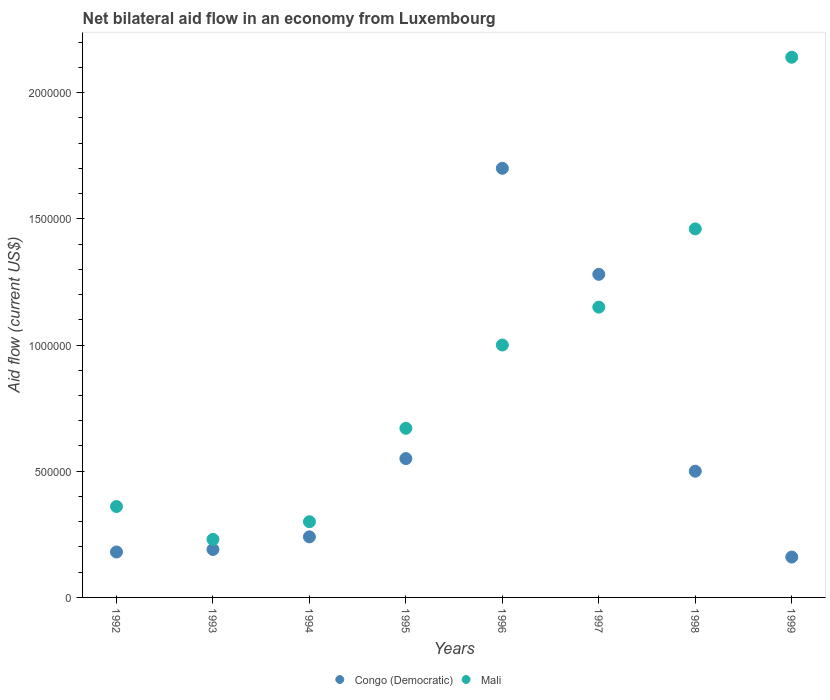What is the net bilateral aid flow in Congo (Democratic) in 1996?
Offer a very short reply. 1.70e+06. Across all years, what is the maximum net bilateral aid flow in Congo (Democratic)?
Ensure brevity in your answer.  1.70e+06. Across all years, what is the minimum net bilateral aid flow in Congo (Democratic)?
Provide a short and direct response. 1.60e+05. In which year was the net bilateral aid flow in Congo (Democratic) maximum?
Provide a succinct answer. 1996. What is the total net bilateral aid flow in Mali in the graph?
Make the answer very short. 7.31e+06. What is the difference between the net bilateral aid flow in Mali in 1992 and that in 1995?
Your answer should be compact. -3.10e+05. What is the difference between the net bilateral aid flow in Mali in 1998 and the net bilateral aid flow in Congo (Democratic) in 1997?
Provide a succinct answer. 1.80e+05. What is the average net bilateral aid flow in Mali per year?
Keep it short and to the point. 9.14e+05. In the year 1996, what is the difference between the net bilateral aid flow in Mali and net bilateral aid flow in Congo (Democratic)?
Your response must be concise. -7.00e+05. What is the ratio of the net bilateral aid flow in Mali in 1994 to that in 1999?
Ensure brevity in your answer.  0.14. What is the difference between the highest and the lowest net bilateral aid flow in Congo (Democratic)?
Make the answer very short. 1.54e+06. In how many years, is the net bilateral aid flow in Congo (Democratic) greater than the average net bilateral aid flow in Congo (Democratic) taken over all years?
Offer a very short reply. 2. Is the sum of the net bilateral aid flow in Congo (Democratic) in 1994 and 1997 greater than the maximum net bilateral aid flow in Mali across all years?
Keep it short and to the point. No. Does the net bilateral aid flow in Congo (Democratic) monotonically increase over the years?
Your response must be concise. No. Is the net bilateral aid flow in Congo (Democratic) strictly less than the net bilateral aid flow in Mali over the years?
Keep it short and to the point. No. How many years are there in the graph?
Make the answer very short. 8. Are the values on the major ticks of Y-axis written in scientific E-notation?
Give a very brief answer. No. Does the graph contain any zero values?
Offer a very short reply. No. How many legend labels are there?
Offer a terse response. 2. What is the title of the graph?
Keep it short and to the point. Net bilateral aid flow in an economy from Luxembourg. What is the label or title of the X-axis?
Your response must be concise. Years. What is the Aid flow (current US$) of Congo (Democratic) in 1992?
Ensure brevity in your answer.  1.80e+05. What is the Aid flow (current US$) of Mali in 1992?
Ensure brevity in your answer.  3.60e+05. What is the Aid flow (current US$) of Mali in 1993?
Keep it short and to the point. 2.30e+05. What is the Aid flow (current US$) of Congo (Democratic) in 1994?
Ensure brevity in your answer.  2.40e+05. What is the Aid flow (current US$) in Congo (Democratic) in 1995?
Give a very brief answer. 5.50e+05. What is the Aid flow (current US$) of Mali in 1995?
Provide a short and direct response. 6.70e+05. What is the Aid flow (current US$) of Congo (Democratic) in 1996?
Offer a terse response. 1.70e+06. What is the Aid flow (current US$) of Congo (Democratic) in 1997?
Offer a terse response. 1.28e+06. What is the Aid flow (current US$) of Mali in 1997?
Make the answer very short. 1.15e+06. What is the Aid flow (current US$) of Mali in 1998?
Give a very brief answer. 1.46e+06. What is the Aid flow (current US$) of Mali in 1999?
Your answer should be very brief. 2.14e+06. Across all years, what is the maximum Aid flow (current US$) of Congo (Democratic)?
Offer a very short reply. 1.70e+06. Across all years, what is the maximum Aid flow (current US$) of Mali?
Ensure brevity in your answer.  2.14e+06. Across all years, what is the minimum Aid flow (current US$) in Mali?
Give a very brief answer. 2.30e+05. What is the total Aid flow (current US$) of Congo (Democratic) in the graph?
Provide a short and direct response. 4.80e+06. What is the total Aid flow (current US$) in Mali in the graph?
Your answer should be very brief. 7.31e+06. What is the difference between the Aid flow (current US$) of Congo (Democratic) in 1992 and that in 1993?
Provide a succinct answer. -10000. What is the difference between the Aid flow (current US$) in Congo (Democratic) in 1992 and that in 1994?
Provide a short and direct response. -6.00e+04. What is the difference between the Aid flow (current US$) of Mali in 1992 and that in 1994?
Keep it short and to the point. 6.00e+04. What is the difference between the Aid flow (current US$) in Congo (Democratic) in 1992 and that in 1995?
Your answer should be compact. -3.70e+05. What is the difference between the Aid flow (current US$) of Mali in 1992 and that in 1995?
Your answer should be compact. -3.10e+05. What is the difference between the Aid flow (current US$) of Congo (Democratic) in 1992 and that in 1996?
Provide a short and direct response. -1.52e+06. What is the difference between the Aid flow (current US$) in Mali in 1992 and that in 1996?
Offer a very short reply. -6.40e+05. What is the difference between the Aid flow (current US$) of Congo (Democratic) in 1992 and that in 1997?
Give a very brief answer. -1.10e+06. What is the difference between the Aid flow (current US$) of Mali in 1992 and that in 1997?
Your response must be concise. -7.90e+05. What is the difference between the Aid flow (current US$) in Congo (Democratic) in 1992 and that in 1998?
Your response must be concise. -3.20e+05. What is the difference between the Aid flow (current US$) in Mali in 1992 and that in 1998?
Your response must be concise. -1.10e+06. What is the difference between the Aid flow (current US$) in Congo (Democratic) in 1992 and that in 1999?
Your response must be concise. 2.00e+04. What is the difference between the Aid flow (current US$) in Mali in 1992 and that in 1999?
Offer a very short reply. -1.78e+06. What is the difference between the Aid flow (current US$) in Mali in 1993 and that in 1994?
Offer a very short reply. -7.00e+04. What is the difference between the Aid flow (current US$) in Congo (Democratic) in 1993 and that in 1995?
Your answer should be very brief. -3.60e+05. What is the difference between the Aid flow (current US$) in Mali in 1993 and that in 1995?
Your answer should be very brief. -4.40e+05. What is the difference between the Aid flow (current US$) of Congo (Democratic) in 1993 and that in 1996?
Offer a very short reply. -1.51e+06. What is the difference between the Aid flow (current US$) in Mali in 1993 and that in 1996?
Your response must be concise. -7.70e+05. What is the difference between the Aid flow (current US$) in Congo (Democratic) in 1993 and that in 1997?
Keep it short and to the point. -1.09e+06. What is the difference between the Aid flow (current US$) of Mali in 1993 and that in 1997?
Offer a terse response. -9.20e+05. What is the difference between the Aid flow (current US$) in Congo (Democratic) in 1993 and that in 1998?
Provide a succinct answer. -3.10e+05. What is the difference between the Aid flow (current US$) in Mali in 1993 and that in 1998?
Give a very brief answer. -1.23e+06. What is the difference between the Aid flow (current US$) in Mali in 1993 and that in 1999?
Provide a short and direct response. -1.91e+06. What is the difference between the Aid flow (current US$) of Congo (Democratic) in 1994 and that in 1995?
Provide a short and direct response. -3.10e+05. What is the difference between the Aid flow (current US$) in Mali in 1994 and that in 1995?
Make the answer very short. -3.70e+05. What is the difference between the Aid flow (current US$) of Congo (Democratic) in 1994 and that in 1996?
Ensure brevity in your answer.  -1.46e+06. What is the difference between the Aid flow (current US$) in Mali in 1994 and that in 1996?
Give a very brief answer. -7.00e+05. What is the difference between the Aid flow (current US$) of Congo (Democratic) in 1994 and that in 1997?
Your answer should be very brief. -1.04e+06. What is the difference between the Aid flow (current US$) in Mali in 1994 and that in 1997?
Your answer should be compact. -8.50e+05. What is the difference between the Aid flow (current US$) of Mali in 1994 and that in 1998?
Offer a very short reply. -1.16e+06. What is the difference between the Aid flow (current US$) of Mali in 1994 and that in 1999?
Provide a short and direct response. -1.84e+06. What is the difference between the Aid flow (current US$) of Congo (Democratic) in 1995 and that in 1996?
Your answer should be very brief. -1.15e+06. What is the difference between the Aid flow (current US$) of Mali in 1995 and that in 1996?
Provide a succinct answer. -3.30e+05. What is the difference between the Aid flow (current US$) in Congo (Democratic) in 1995 and that in 1997?
Make the answer very short. -7.30e+05. What is the difference between the Aid flow (current US$) of Mali in 1995 and that in 1997?
Give a very brief answer. -4.80e+05. What is the difference between the Aid flow (current US$) of Mali in 1995 and that in 1998?
Offer a terse response. -7.90e+05. What is the difference between the Aid flow (current US$) of Mali in 1995 and that in 1999?
Make the answer very short. -1.47e+06. What is the difference between the Aid flow (current US$) of Congo (Democratic) in 1996 and that in 1997?
Your answer should be compact. 4.20e+05. What is the difference between the Aid flow (current US$) of Mali in 1996 and that in 1997?
Provide a succinct answer. -1.50e+05. What is the difference between the Aid flow (current US$) in Congo (Democratic) in 1996 and that in 1998?
Your answer should be very brief. 1.20e+06. What is the difference between the Aid flow (current US$) of Mali in 1996 and that in 1998?
Your answer should be compact. -4.60e+05. What is the difference between the Aid flow (current US$) of Congo (Democratic) in 1996 and that in 1999?
Your answer should be very brief. 1.54e+06. What is the difference between the Aid flow (current US$) of Mali in 1996 and that in 1999?
Offer a terse response. -1.14e+06. What is the difference between the Aid flow (current US$) in Congo (Democratic) in 1997 and that in 1998?
Your answer should be very brief. 7.80e+05. What is the difference between the Aid flow (current US$) in Mali in 1997 and that in 1998?
Keep it short and to the point. -3.10e+05. What is the difference between the Aid flow (current US$) of Congo (Democratic) in 1997 and that in 1999?
Your response must be concise. 1.12e+06. What is the difference between the Aid flow (current US$) of Mali in 1997 and that in 1999?
Your answer should be very brief. -9.90e+05. What is the difference between the Aid flow (current US$) in Congo (Democratic) in 1998 and that in 1999?
Your answer should be compact. 3.40e+05. What is the difference between the Aid flow (current US$) of Mali in 1998 and that in 1999?
Provide a succinct answer. -6.80e+05. What is the difference between the Aid flow (current US$) of Congo (Democratic) in 1992 and the Aid flow (current US$) of Mali in 1993?
Offer a very short reply. -5.00e+04. What is the difference between the Aid flow (current US$) in Congo (Democratic) in 1992 and the Aid flow (current US$) in Mali in 1994?
Provide a succinct answer. -1.20e+05. What is the difference between the Aid flow (current US$) of Congo (Democratic) in 1992 and the Aid flow (current US$) of Mali in 1995?
Provide a succinct answer. -4.90e+05. What is the difference between the Aid flow (current US$) in Congo (Democratic) in 1992 and the Aid flow (current US$) in Mali in 1996?
Your response must be concise. -8.20e+05. What is the difference between the Aid flow (current US$) of Congo (Democratic) in 1992 and the Aid flow (current US$) of Mali in 1997?
Offer a terse response. -9.70e+05. What is the difference between the Aid flow (current US$) in Congo (Democratic) in 1992 and the Aid flow (current US$) in Mali in 1998?
Offer a terse response. -1.28e+06. What is the difference between the Aid flow (current US$) in Congo (Democratic) in 1992 and the Aid flow (current US$) in Mali in 1999?
Provide a succinct answer. -1.96e+06. What is the difference between the Aid flow (current US$) in Congo (Democratic) in 1993 and the Aid flow (current US$) in Mali in 1995?
Offer a very short reply. -4.80e+05. What is the difference between the Aid flow (current US$) in Congo (Democratic) in 1993 and the Aid flow (current US$) in Mali in 1996?
Ensure brevity in your answer.  -8.10e+05. What is the difference between the Aid flow (current US$) of Congo (Democratic) in 1993 and the Aid flow (current US$) of Mali in 1997?
Offer a terse response. -9.60e+05. What is the difference between the Aid flow (current US$) in Congo (Democratic) in 1993 and the Aid flow (current US$) in Mali in 1998?
Keep it short and to the point. -1.27e+06. What is the difference between the Aid flow (current US$) of Congo (Democratic) in 1993 and the Aid flow (current US$) of Mali in 1999?
Provide a short and direct response. -1.95e+06. What is the difference between the Aid flow (current US$) of Congo (Democratic) in 1994 and the Aid flow (current US$) of Mali in 1995?
Make the answer very short. -4.30e+05. What is the difference between the Aid flow (current US$) in Congo (Democratic) in 1994 and the Aid flow (current US$) in Mali in 1996?
Your response must be concise. -7.60e+05. What is the difference between the Aid flow (current US$) in Congo (Democratic) in 1994 and the Aid flow (current US$) in Mali in 1997?
Ensure brevity in your answer.  -9.10e+05. What is the difference between the Aid flow (current US$) in Congo (Democratic) in 1994 and the Aid flow (current US$) in Mali in 1998?
Offer a terse response. -1.22e+06. What is the difference between the Aid flow (current US$) of Congo (Democratic) in 1994 and the Aid flow (current US$) of Mali in 1999?
Your answer should be compact. -1.90e+06. What is the difference between the Aid flow (current US$) of Congo (Democratic) in 1995 and the Aid flow (current US$) of Mali in 1996?
Provide a succinct answer. -4.50e+05. What is the difference between the Aid flow (current US$) of Congo (Democratic) in 1995 and the Aid flow (current US$) of Mali in 1997?
Ensure brevity in your answer.  -6.00e+05. What is the difference between the Aid flow (current US$) in Congo (Democratic) in 1995 and the Aid flow (current US$) in Mali in 1998?
Offer a terse response. -9.10e+05. What is the difference between the Aid flow (current US$) of Congo (Democratic) in 1995 and the Aid flow (current US$) of Mali in 1999?
Offer a terse response. -1.59e+06. What is the difference between the Aid flow (current US$) in Congo (Democratic) in 1996 and the Aid flow (current US$) in Mali in 1997?
Your answer should be compact. 5.50e+05. What is the difference between the Aid flow (current US$) in Congo (Democratic) in 1996 and the Aid flow (current US$) in Mali in 1998?
Offer a very short reply. 2.40e+05. What is the difference between the Aid flow (current US$) in Congo (Democratic) in 1996 and the Aid flow (current US$) in Mali in 1999?
Give a very brief answer. -4.40e+05. What is the difference between the Aid flow (current US$) of Congo (Democratic) in 1997 and the Aid flow (current US$) of Mali in 1998?
Your answer should be very brief. -1.80e+05. What is the difference between the Aid flow (current US$) in Congo (Democratic) in 1997 and the Aid flow (current US$) in Mali in 1999?
Your response must be concise. -8.60e+05. What is the difference between the Aid flow (current US$) in Congo (Democratic) in 1998 and the Aid flow (current US$) in Mali in 1999?
Your response must be concise. -1.64e+06. What is the average Aid flow (current US$) of Congo (Democratic) per year?
Make the answer very short. 6.00e+05. What is the average Aid flow (current US$) of Mali per year?
Ensure brevity in your answer.  9.14e+05. In the year 1993, what is the difference between the Aid flow (current US$) in Congo (Democratic) and Aid flow (current US$) in Mali?
Offer a terse response. -4.00e+04. In the year 1994, what is the difference between the Aid flow (current US$) in Congo (Democratic) and Aid flow (current US$) in Mali?
Your answer should be very brief. -6.00e+04. In the year 1995, what is the difference between the Aid flow (current US$) of Congo (Democratic) and Aid flow (current US$) of Mali?
Give a very brief answer. -1.20e+05. In the year 1997, what is the difference between the Aid flow (current US$) of Congo (Democratic) and Aid flow (current US$) of Mali?
Ensure brevity in your answer.  1.30e+05. In the year 1998, what is the difference between the Aid flow (current US$) of Congo (Democratic) and Aid flow (current US$) of Mali?
Make the answer very short. -9.60e+05. In the year 1999, what is the difference between the Aid flow (current US$) in Congo (Democratic) and Aid flow (current US$) in Mali?
Provide a short and direct response. -1.98e+06. What is the ratio of the Aid flow (current US$) in Mali in 1992 to that in 1993?
Ensure brevity in your answer.  1.57. What is the ratio of the Aid flow (current US$) of Congo (Democratic) in 1992 to that in 1995?
Ensure brevity in your answer.  0.33. What is the ratio of the Aid flow (current US$) in Mali in 1992 to that in 1995?
Give a very brief answer. 0.54. What is the ratio of the Aid flow (current US$) of Congo (Democratic) in 1992 to that in 1996?
Your response must be concise. 0.11. What is the ratio of the Aid flow (current US$) of Mali in 1992 to that in 1996?
Offer a terse response. 0.36. What is the ratio of the Aid flow (current US$) of Congo (Democratic) in 1992 to that in 1997?
Your response must be concise. 0.14. What is the ratio of the Aid flow (current US$) in Mali in 1992 to that in 1997?
Offer a very short reply. 0.31. What is the ratio of the Aid flow (current US$) of Congo (Democratic) in 1992 to that in 1998?
Give a very brief answer. 0.36. What is the ratio of the Aid flow (current US$) in Mali in 1992 to that in 1998?
Your response must be concise. 0.25. What is the ratio of the Aid flow (current US$) of Congo (Democratic) in 1992 to that in 1999?
Your response must be concise. 1.12. What is the ratio of the Aid flow (current US$) in Mali in 1992 to that in 1999?
Give a very brief answer. 0.17. What is the ratio of the Aid flow (current US$) in Congo (Democratic) in 1993 to that in 1994?
Provide a succinct answer. 0.79. What is the ratio of the Aid flow (current US$) of Mali in 1993 to that in 1994?
Provide a short and direct response. 0.77. What is the ratio of the Aid flow (current US$) in Congo (Democratic) in 1993 to that in 1995?
Ensure brevity in your answer.  0.35. What is the ratio of the Aid flow (current US$) of Mali in 1993 to that in 1995?
Make the answer very short. 0.34. What is the ratio of the Aid flow (current US$) of Congo (Democratic) in 1993 to that in 1996?
Provide a short and direct response. 0.11. What is the ratio of the Aid flow (current US$) of Mali in 1993 to that in 1996?
Offer a very short reply. 0.23. What is the ratio of the Aid flow (current US$) of Congo (Democratic) in 1993 to that in 1997?
Make the answer very short. 0.15. What is the ratio of the Aid flow (current US$) in Mali in 1993 to that in 1997?
Make the answer very short. 0.2. What is the ratio of the Aid flow (current US$) in Congo (Democratic) in 1993 to that in 1998?
Your answer should be very brief. 0.38. What is the ratio of the Aid flow (current US$) of Mali in 1993 to that in 1998?
Give a very brief answer. 0.16. What is the ratio of the Aid flow (current US$) in Congo (Democratic) in 1993 to that in 1999?
Offer a terse response. 1.19. What is the ratio of the Aid flow (current US$) of Mali in 1993 to that in 1999?
Keep it short and to the point. 0.11. What is the ratio of the Aid flow (current US$) of Congo (Democratic) in 1994 to that in 1995?
Keep it short and to the point. 0.44. What is the ratio of the Aid flow (current US$) in Mali in 1994 to that in 1995?
Your response must be concise. 0.45. What is the ratio of the Aid flow (current US$) of Congo (Democratic) in 1994 to that in 1996?
Ensure brevity in your answer.  0.14. What is the ratio of the Aid flow (current US$) in Mali in 1994 to that in 1996?
Keep it short and to the point. 0.3. What is the ratio of the Aid flow (current US$) of Congo (Democratic) in 1994 to that in 1997?
Ensure brevity in your answer.  0.19. What is the ratio of the Aid flow (current US$) in Mali in 1994 to that in 1997?
Ensure brevity in your answer.  0.26. What is the ratio of the Aid flow (current US$) in Congo (Democratic) in 1994 to that in 1998?
Your answer should be compact. 0.48. What is the ratio of the Aid flow (current US$) in Mali in 1994 to that in 1998?
Ensure brevity in your answer.  0.21. What is the ratio of the Aid flow (current US$) of Mali in 1994 to that in 1999?
Offer a very short reply. 0.14. What is the ratio of the Aid flow (current US$) of Congo (Democratic) in 1995 to that in 1996?
Ensure brevity in your answer.  0.32. What is the ratio of the Aid flow (current US$) in Mali in 1995 to that in 1996?
Your answer should be compact. 0.67. What is the ratio of the Aid flow (current US$) of Congo (Democratic) in 1995 to that in 1997?
Ensure brevity in your answer.  0.43. What is the ratio of the Aid flow (current US$) in Mali in 1995 to that in 1997?
Your response must be concise. 0.58. What is the ratio of the Aid flow (current US$) of Mali in 1995 to that in 1998?
Provide a short and direct response. 0.46. What is the ratio of the Aid flow (current US$) in Congo (Democratic) in 1995 to that in 1999?
Keep it short and to the point. 3.44. What is the ratio of the Aid flow (current US$) in Mali in 1995 to that in 1999?
Keep it short and to the point. 0.31. What is the ratio of the Aid flow (current US$) in Congo (Democratic) in 1996 to that in 1997?
Give a very brief answer. 1.33. What is the ratio of the Aid flow (current US$) of Mali in 1996 to that in 1997?
Give a very brief answer. 0.87. What is the ratio of the Aid flow (current US$) of Congo (Democratic) in 1996 to that in 1998?
Make the answer very short. 3.4. What is the ratio of the Aid flow (current US$) of Mali in 1996 to that in 1998?
Keep it short and to the point. 0.68. What is the ratio of the Aid flow (current US$) in Congo (Democratic) in 1996 to that in 1999?
Provide a succinct answer. 10.62. What is the ratio of the Aid flow (current US$) in Mali in 1996 to that in 1999?
Offer a terse response. 0.47. What is the ratio of the Aid flow (current US$) in Congo (Democratic) in 1997 to that in 1998?
Ensure brevity in your answer.  2.56. What is the ratio of the Aid flow (current US$) of Mali in 1997 to that in 1998?
Ensure brevity in your answer.  0.79. What is the ratio of the Aid flow (current US$) in Congo (Democratic) in 1997 to that in 1999?
Ensure brevity in your answer.  8. What is the ratio of the Aid flow (current US$) in Mali in 1997 to that in 1999?
Provide a short and direct response. 0.54. What is the ratio of the Aid flow (current US$) in Congo (Democratic) in 1998 to that in 1999?
Your response must be concise. 3.12. What is the ratio of the Aid flow (current US$) in Mali in 1998 to that in 1999?
Offer a terse response. 0.68. What is the difference between the highest and the second highest Aid flow (current US$) in Congo (Democratic)?
Offer a terse response. 4.20e+05. What is the difference between the highest and the second highest Aid flow (current US$) in Mali?
Ensure brevity in your answer.  6.80e+05. What is the difference between the highest and the lowest Aid flow (current US$) of Congo (Democratic)?
Ensure brevity in your answer.  1.54e+06. What is the difference between the highest and the lowest Aid flow (current US$) of Mali?
Offer a very short reply. 1.91e+06. 